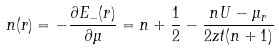<formula> <loc_0><loc_0><loc_500><loc_500>n ( r ) = - \frac { \partial E _ { - } ( r ) } { \partial \mu } = n + \frac { 1 } { 2 } - \frac { n U - \mu _ { r } } { 2 z t ( n + 1 ) }</formula> 